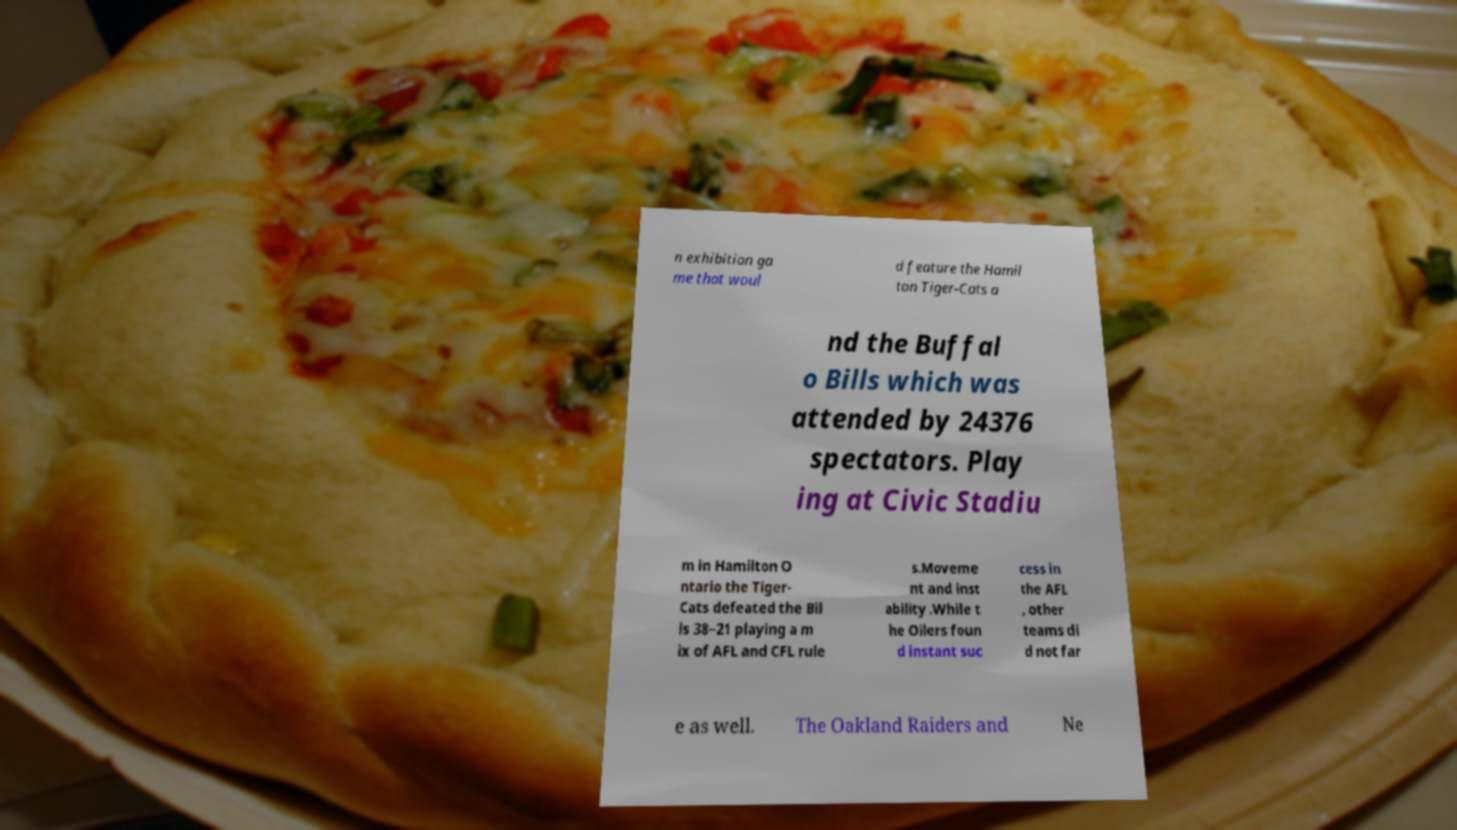Can you read and provide the text displayed in the image?This photo seems to have some interesting text. Can you extract and type it out for me? n exhibition ga me that woul d feature the Hamil ton Tiger-Cats a nd the Buffal o Bills which was attended by 24376 spectators. Play ing at Civic Stadiu m in Hamilton O ntario the Tiger- Cats defeated the Bil ls 38–21 playing a m ix of AFL and CFL rule s.Moveme nt and inst ability .While t he Oilers foun d instant suc cess in the AFL , other teams di d not far e as well. The Oakland Raiders and Ne 